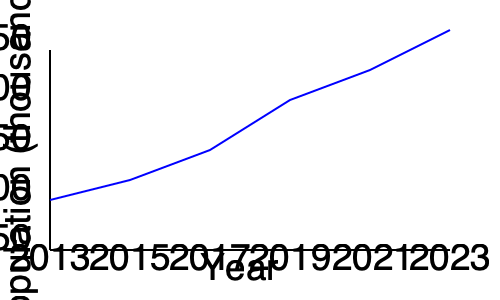Based on the population growth chart for Agbor over the past decade, what is the estimated population growth rate between 2019 and 2023? To calculate the estimated population growth rate between 2019 and 2023:

1. Determine the population in 2019:
   From the chart, the 2019 population is approximately 200,000.

2. Determine the population in 2023:
   From the chart, the 2023 population is approximately 240,000.

3. Calculate the total growth:
   $240,000 - 200,000 = 40,000$

4. Calculate the growth rate:
   Growth rate = (Change in population / Initial population) × 100
   $\frac{40,000}{200,000} \times 100 = 0.2 \times 100 = 20\%$

5. Convert to annual growth rate:
   Time period = 4 years (2019 to 2023)
   Annual growth rate = Total growth rate / Number of years
   $20\% \div 4 = 5\%$ per year

Therefore, the estimated annual population growth rate between 2019 and 2023 is 5%.
Answer: 5% per year 